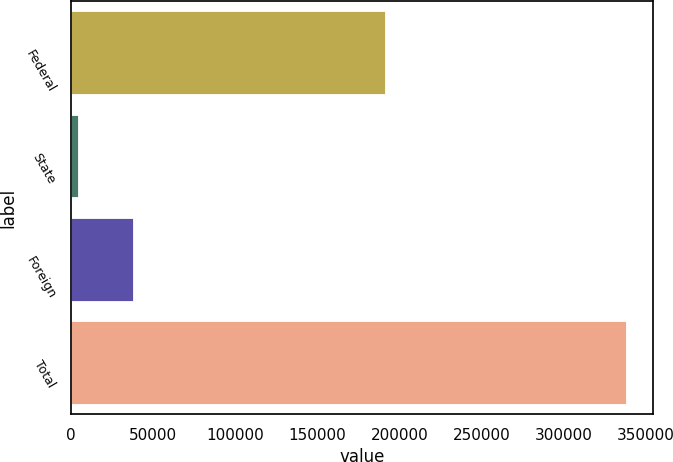Convert chart to OTSL. <chart><loc_0><loc_0><loc_500><loc_500><bar_chart><fcel>Federal<fcel>State<fcel>Foreign<fcel>Total<nl><fcel>191006<fcel>4221<fcel>37557.6<fcel>337587<nl></chart> 